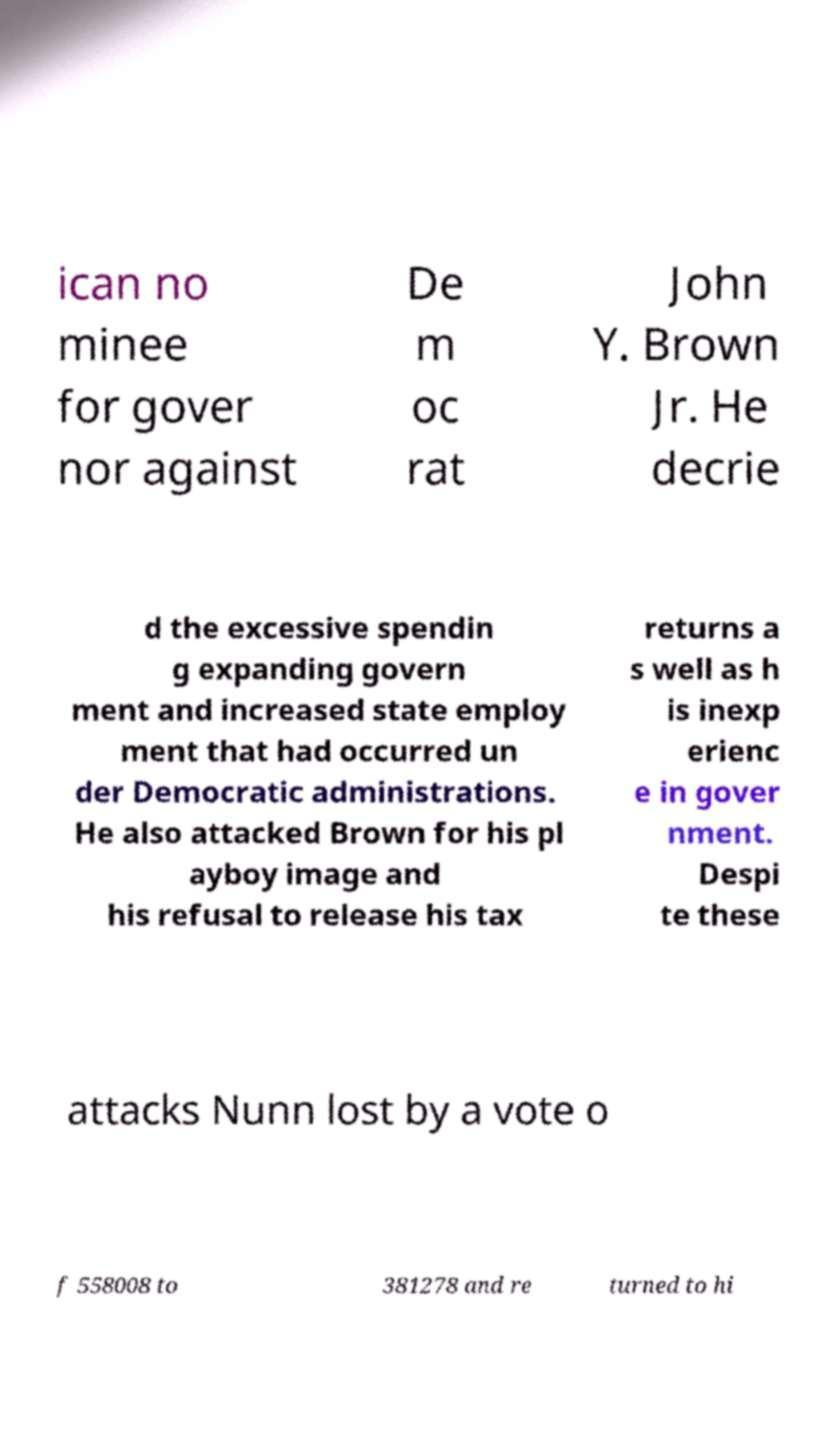Could you extract and type out the text from this image? ican no minee for gover nor against De m oc rat John Y. Brown Jr. He decrie d the excessive spendin g expanding govern ment and increased state employ ment that had occurred un der Democratic administrations. He also attacked Brown for his pl ayboy image and his refusal to release his tax returns a s well as h is inexp erienc e in gover nment. Despi te these attacks Nunn lost by a vote o f 558008 to 381278 and re turned to hi 